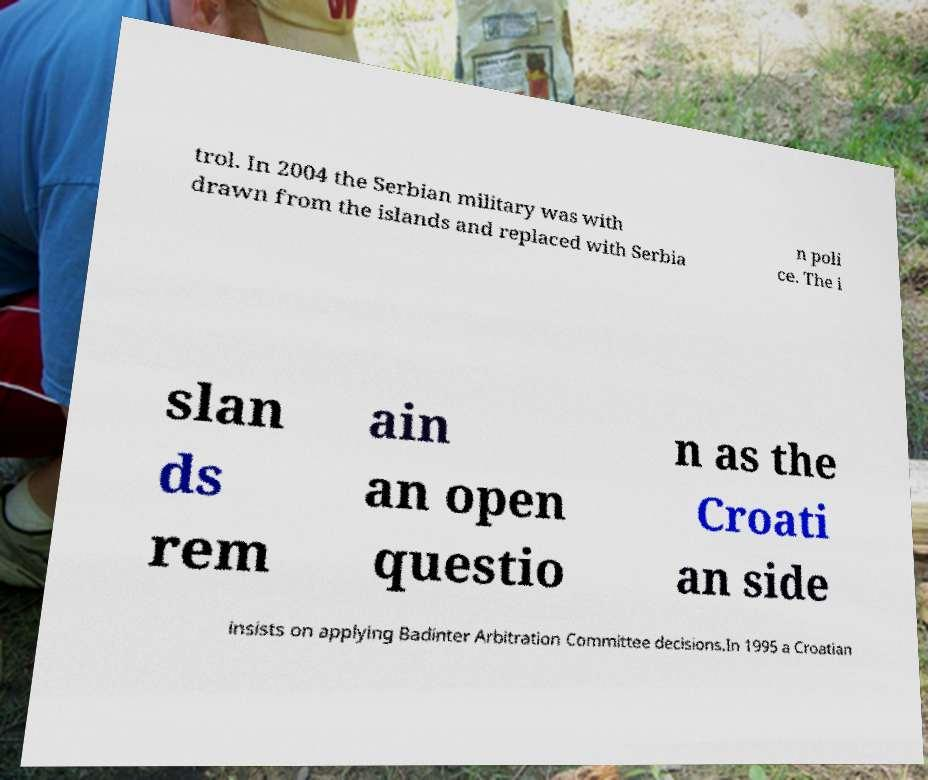Please identify and transcribe the text found in this image. trol. In 2004 the Serbian military was with drawn from the islands and replaced with Serbia n poli ce. The i slan ds rem ain an open questio n as the Croati an side insists on applying Badinter Arbitration Committee decisions.In 1995 a Croatian 